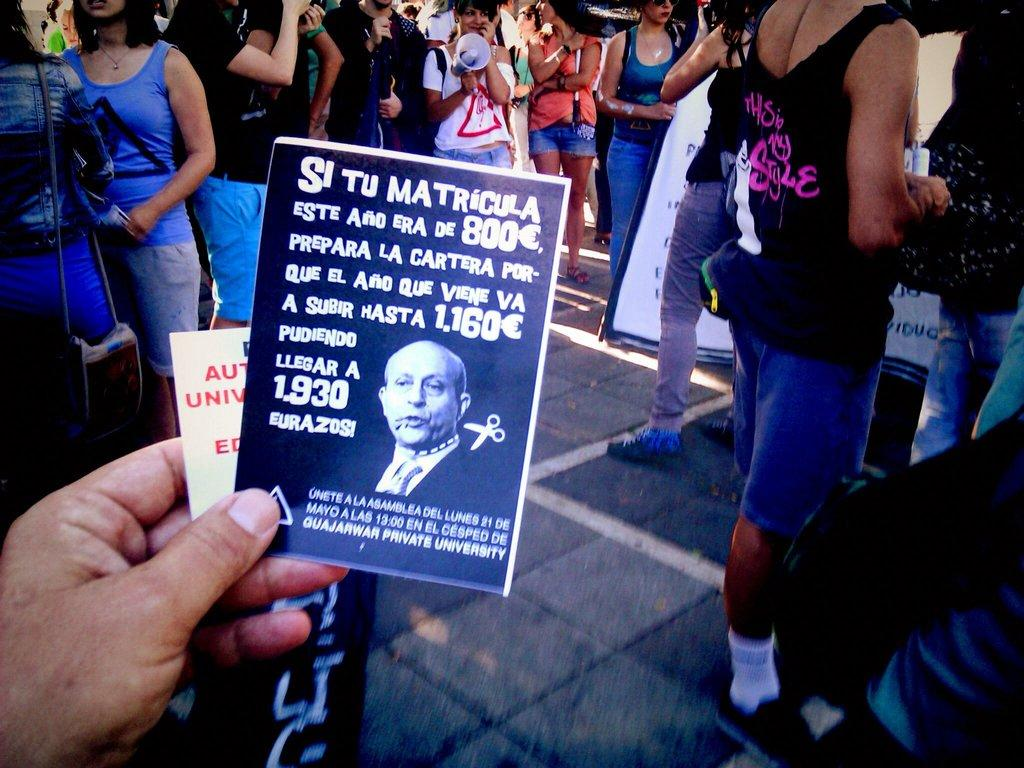What is the person in the image holding? The person is holding an article in the image. What can be found on the article? There is text on the article. Can you describe the background of the image? There are people standing in the background of the image. Where is the goose sitting on the throne in the image? There is no goose or throne present in the image. What color are the person's toes in the image? The provided facts do not mention the person's toes, so we cannot determine their color from the image. 